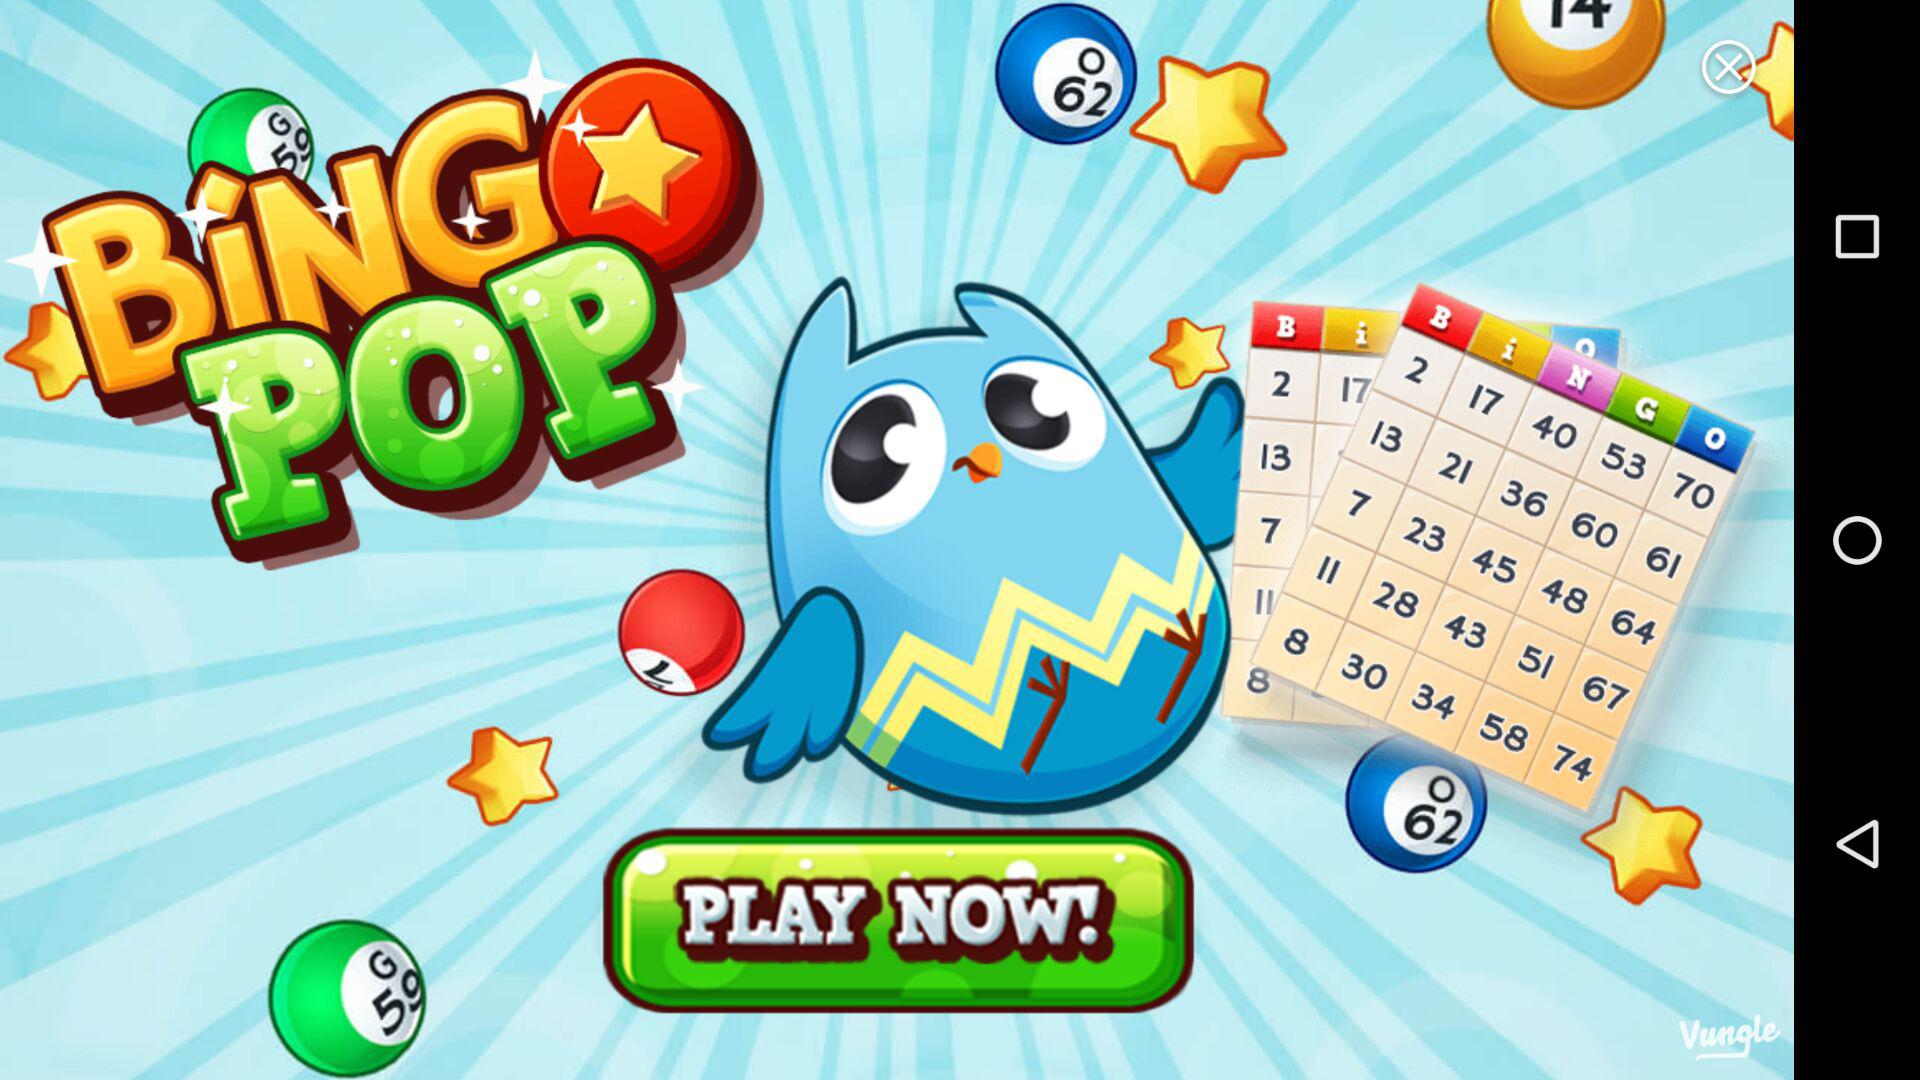How many tickets can we get on Day 4? You can get 20 tickets on day 4. 